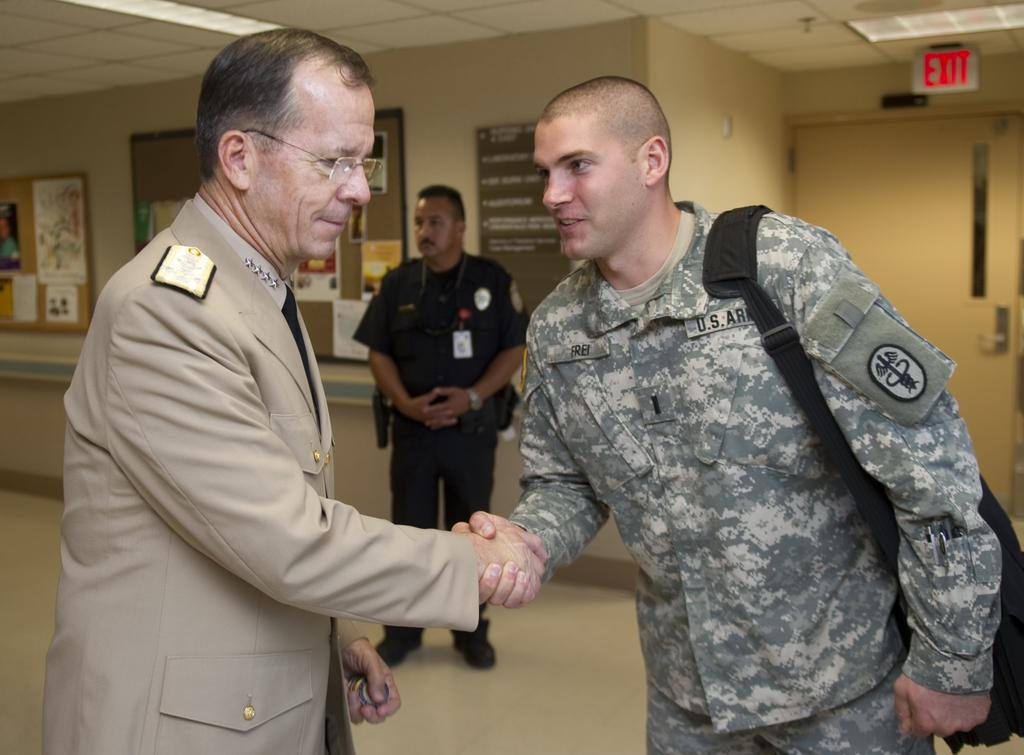What are the two men in the image doing? The two men in the image are standing and holding hands. Can you describe the background of the image? In the background, there is a man standing. Where are the posters located in the image? The posters are on boards, a wall, and a door. What type of marble is visible in the image? There is no marble present in the image. What kind of truck can be seen in the background of the image? There is no truck visible in the image. 